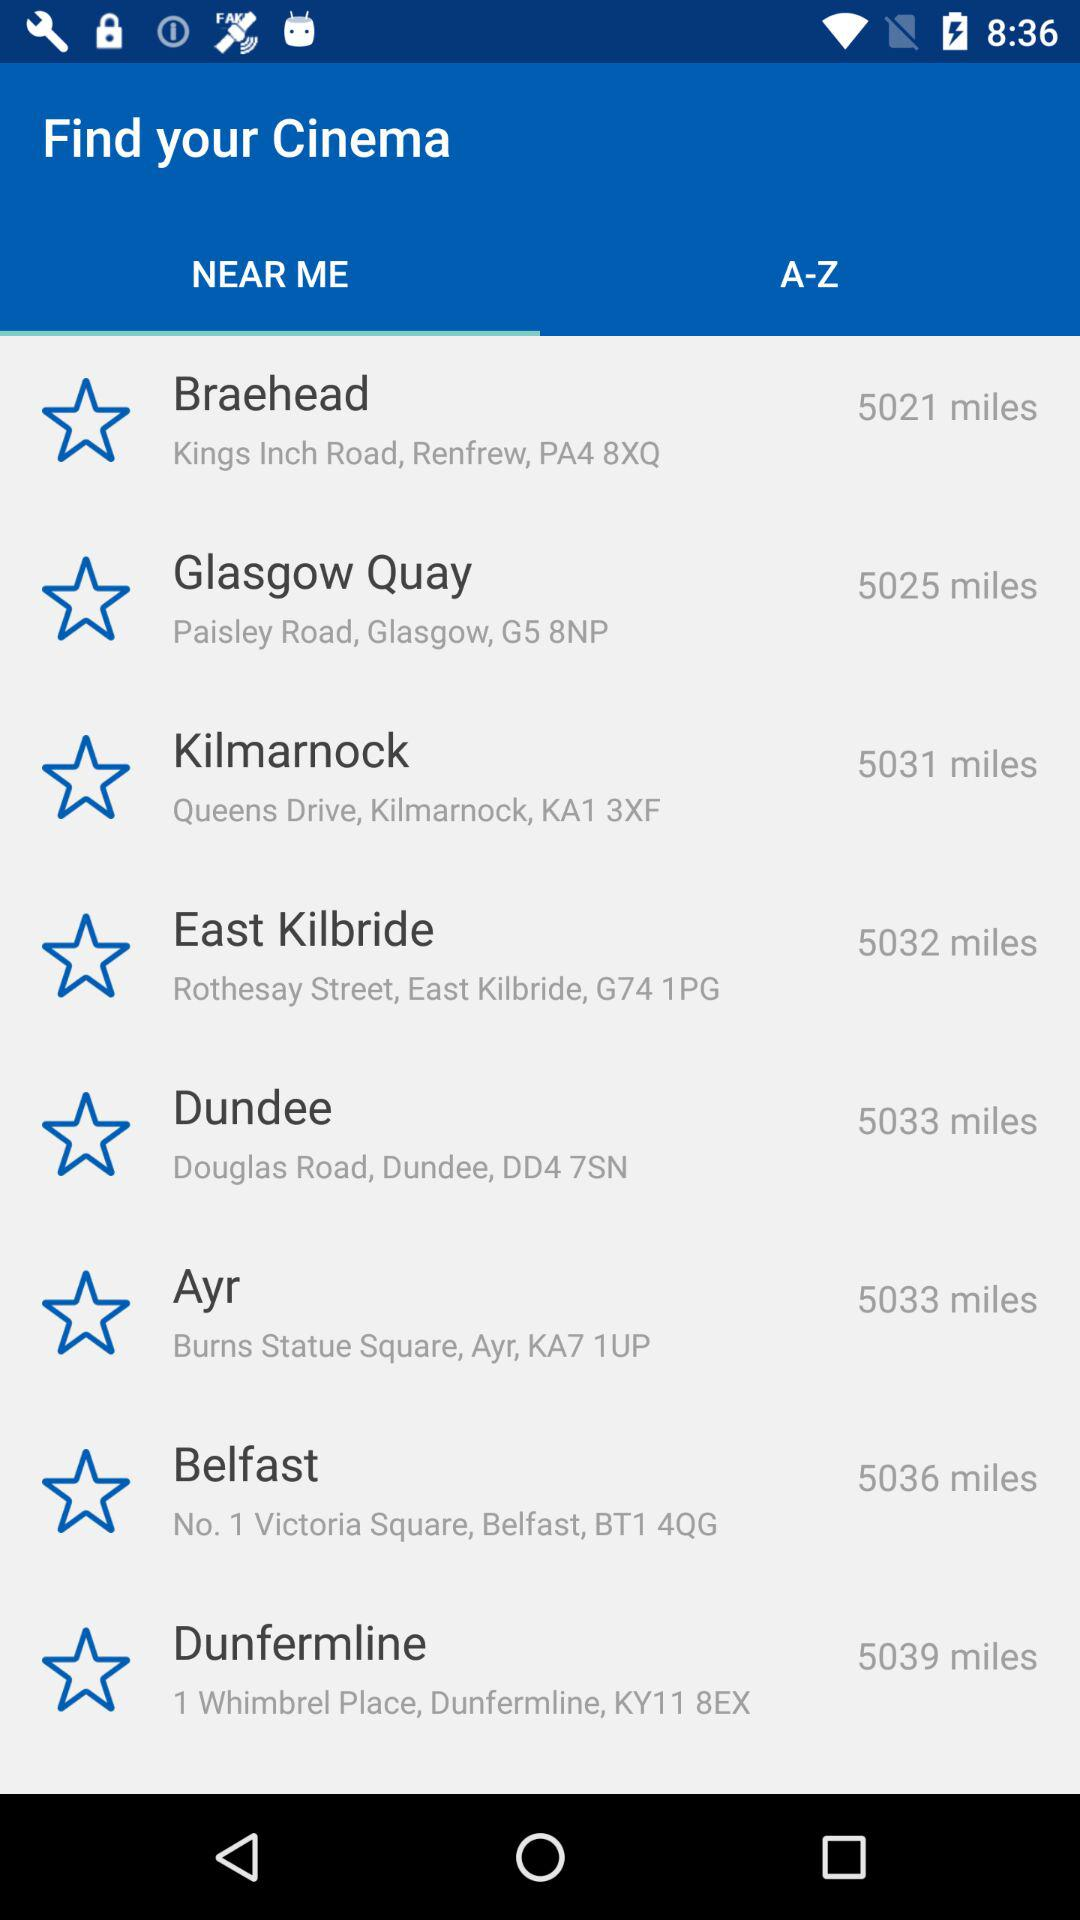What is the address of the Ayr? The address is Burns Statue Square, Ayr, KA7 1UP. 